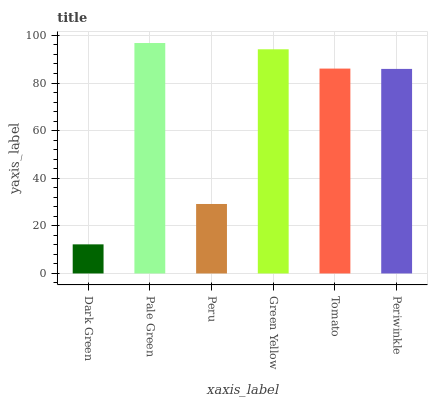Is Dark Green the minimum?
Answer yes or no. Yes. Is Pale Green the maximum?
Answer yes or no. Yes. Is Peru the minimum?
Answer yes or no. No. Is Peru the maximum?
Answer yes or no. No. Is Pale Green greater than Peru?
Answer yes or no. Yes. Is Peru less than Pale Green?
Answer yes or no. Yes. Is Peru greater than Pale Green?
Answer yes or no. No. Is Pale Green less than Peru?
Answer yes or no. No. Is Tomato the high median?
Answer yes or no. Yes. Is Periwinkle the low median?
Answer yes or no. Yes. Is Green Yellow the high median?
Answer yes or no. No. Is Peru the low median?
Answer yes or no. No. 